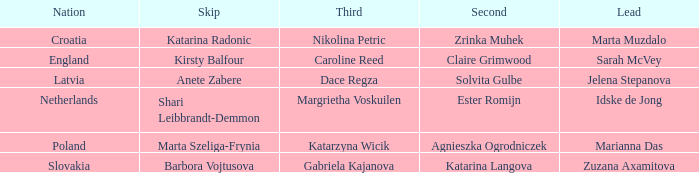Who is the Second with Nikolina Petric as Third? Zrinka Muhek. 